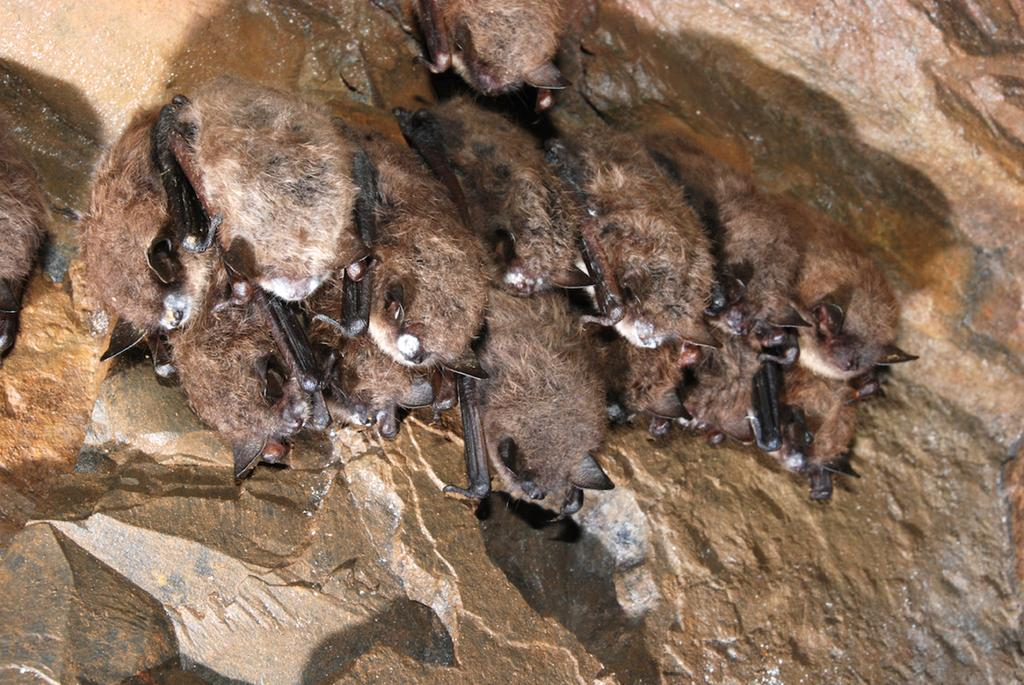What type of animals are present in the image? There are brown-colored bats in the image. What is the tendency of the cart in the image? There is no cart present in the image, so it is not possible to determine its tendency. 